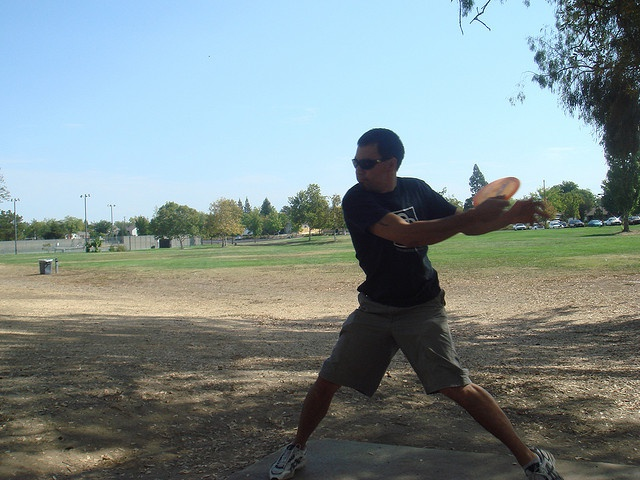Describe the objects in this image and their specific colors. I can see people in lightblue, black, gray, and navy tones, frisbee in lightblue, gray, tan, and white tones, car in lightblue, gray, black, and teal tones, car in lightblue, gray, darkgray, white, and black tones, and car in lightblue, darkgray, gray, and white tones in this image. 